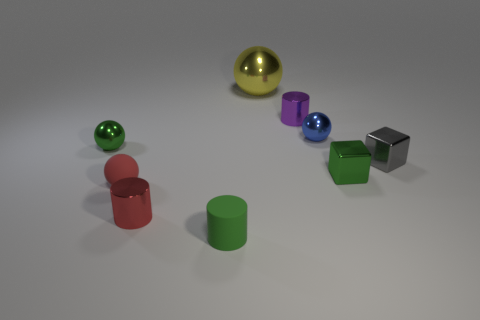Subtract all small matte cylinders. How many cylinders are left? 2 Add 1 red shiny cylinders. How many objects exist? 10 Subtract all green cylinders. How many cylinders are left? 2 Subtract all cylinders. How many objects are left? 6 Subtract all green cylinders. Subtract all green cubes. How many cylinders are left? 2 Subtract all tiny blocks. Subtract all small green rubber cylinders. How many objects are left? 6 Add 8 red cylinders. How many red cylinders are left? 9 Add 3 tiny red metal cylinders. How many tiny red metal cylinders exist? 4 Subtract 1 purple cylinders. How many objects are left? 8 